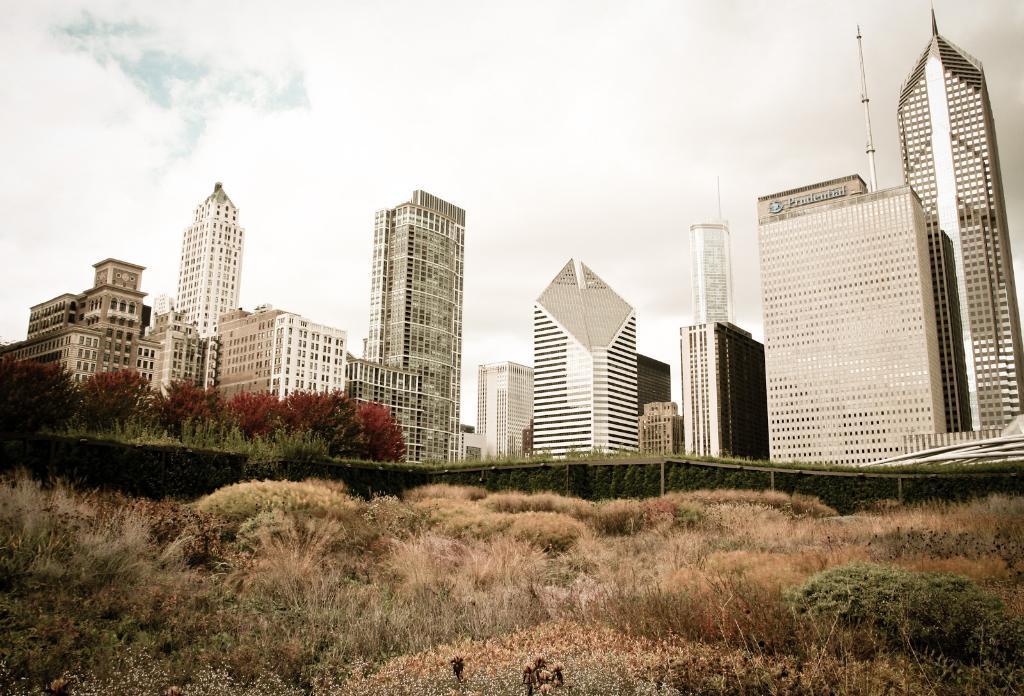Describe this image in one or two sentences. In this image I can see there are building ,grass visible at the bottom ,at the top there is the sky visible. 